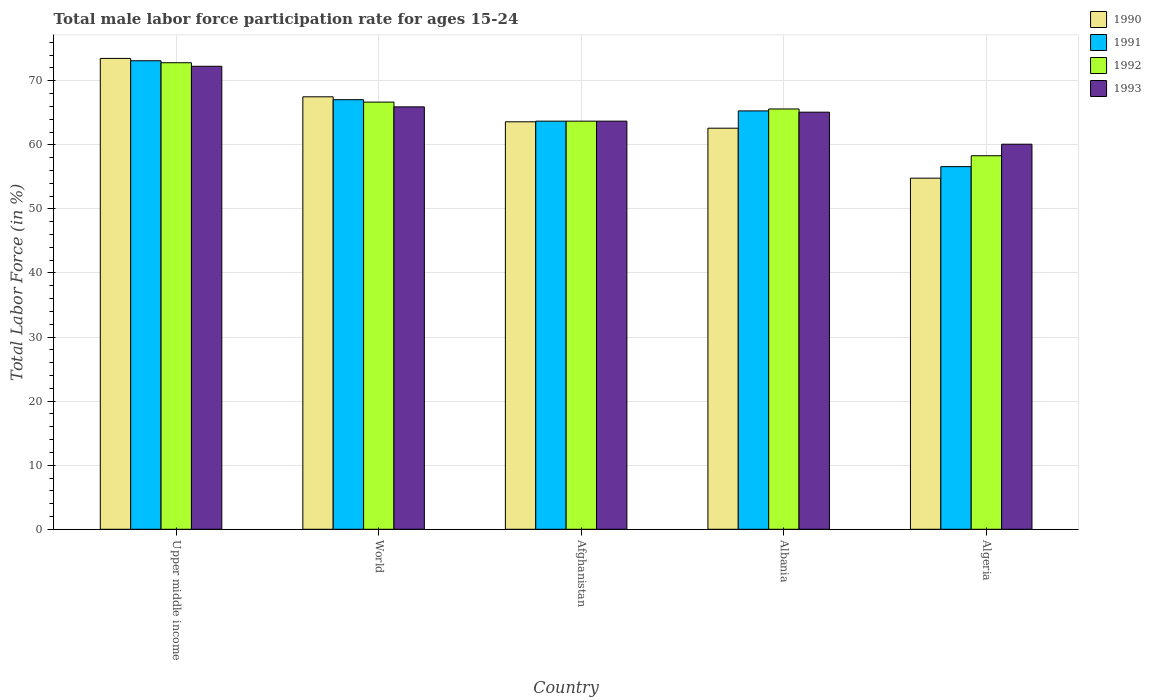How many bars are there on the 4th tick from the left?
Ensure brevity in your answer.  4. How many bars are there on the 3rd tick from the right?
Make the answer very short. 4. What is the label of the 5th group of bars from the left?
Make the answer very short. Algeria. What is the male labor force participation rate in 1991 in Afghanistan?
Your answer should be very brief. 63.7. Across all countries, what is the maximum male labor force participation rate in 1993?
Give a very brief answer. 72.26. Across all countries, what is the minimum male labor force participation rate in 1993?
Give a very brief answer. 60.1. In which country was the male labor force participation rate in 1990 maximum?
Ensure brevity in your answer.  Upper middle income. In which country was the male labor force participation rate in 1993 minimum?
Your answer should be compact. Algeria. What is the total male labor force participation rate in 1993 in the graph?
Provide a short and direct response. 327.09. What is the difference between the male labor force participation rate in 1992 in Algeria and that in World?
Provide a short and direct response. -8.37. What is the difference between the male labor force participation rate in 1992 in Upper middle income and the male labor force participation rate in 1990 in Albania?
Your answer should be very brief. 10.22. What is the average male labor force participation rate in 1991 per country?
Offer a terse response. 65.16. What is the difference between the male labor force participation rate of/in 1992 and male labor force participation rate of/in 1993 in Albania?
Your answer should be compact. 0.5. In how many countries, is the male labor force participation rate in 1992 greater than 10 %?
Your answer should be compact. 5. What is the ratio of the male labor force participation rate in 1992 in Afghanistan to that in Algeria?
Your answer should be very brief. 1.09. What is the difference between the highest and the second highest male labor force participation rate in 1990?
Make the answer very short. 5.99. What is the difference between the highest and the lowest male labor force participation rate in 1992?
Offer a terse response. 14.52. Is the sum of the male labor force participation rate in 1993 in Upper middle income and World greater than the maximum male labor force participation rate in 1991 across all countries?
Give a very brief answer. Yes. What does the 4th bar from the left in Albania represents?
Your answer should be very brief. 1993. What does the 4th bar from the right in Afghanistan represents?
Your answer should be very brief. 1990. Is it the case that in every country, the sum of the male labor force participation rate in 1991 and male labor force participation rate in 1992 is greater than the male labor force participation rate in 1990?
Your answer should be compact. Yes. Are all the bars in the graph horizontal?
Ensure brevity in your answer.  No. Are the values on the major ticks of Y-axis written in scientific E-notation?
Ensure brevity in your answer.  No. Does the graph contain any zero values?
Ensure brevity in your answer.  No. How many legend labels are there?
Provide a succinct answer. 4. How are the legend labels stacked?
Provide a short and direct response. Vertical. What is the title of the graph?
Ensure brevity in your answer.  Total male labor force participation rate for ages 15-24. What is the label or title of the X-axis?
Offer a very short reply. Country. What is the label or title of the Y-axis?
Your response must be concise. Total Labor Force (in %). What is the Total Labor Force (in %) in 1990 in Upper middle income?
Ensure brevity in your answer.  73.49. What is the Total Labor Force (in %) of 1991 in Upper middle income?
Make the answer very short. 73.13. What is the Total Labor Force (in %) in 1992 in Upper middle income?
Your answer should be compact. 72.82. What is the Total Labor Force (in %) in 1993 in Upper middle income?
Provide a short and direct response. 72.26. What is the Total Labor Force (in %) in 1990 in World?
Provide a succinct answer. 67.5. What is the Total Labor Force (in %) of 1991 in World?
Offer a terse response. 67.05. What is the Total Labor Force (in %) in 1992 in World?
Keep it short and to the point. 66.67. What is the Total Labor Force (in %) of 1993 in World?
Make the answer very short. 65.93. What is the Total Labor Force (in %) of 1990 in Afghanistan?
Give a very brief answer. 63.6. What is the Total Labor Force (in %) in 1991 in Afghanistan?
Ensure brevity in your answer.  63.7. What is the Total Labor Force (in %) in 1992 in Afghanistan?
Offer a terse response. 63.7. What is the Total Labor Force (in %) in 1993 in Afghanistan?
Offer a very short reply. 63.7. What is the Total Labor Force (in %) in 1990 in Albania?
Keep it short and to the point. 62.6. What is the Total Labor Force (in %) of 1991 in Albania?
Offer a terse response. 65.3. What is the Total Labor Force (in %) of 1992 in Albania?
Give a very brief answer. 65.6. What is the Total Labor Force (in %) in 1993 in Albania?
Give a very brief answer. 65.1. What is the Total Labor Force (in %) of 1990 in Algeria?
Provide a succinct answer. 54.8. What is the Total Labor Force (in %) in 1991 in Algeria?
Your response must be concise. 56.6. What is the Total Labor Force (in %) of 1992 in Algeria?
Offer a very short reply. 58.3. What is the Total Labor Force (in %) of 1993 in Algeria?
Provide a succinct answer. 60.1. Across all countries, what is the maximum Total Labor Force (in %) of 1990?
Keep it short and to the point. 73.49. Across all countries, what is the maximum Total Labor Force (in %) in 1991?
Offer a very short reply. 73.13. Across all countries, what is the maximum Total Labor Force (in %) in 1992?
Provide a succinct answer. 72.82. Across all countries, what is the maximum Total Labor Force (in %) in 1993?
Make the answer very short. 72.26. Across all countries, what is the minimum Total Labor Force (in %) of 1990?
Your response must be concise. 54.8. Across all countries, what is the minimum Total Labor Force (in %) of 1991?
Your answer should be compact. 56.6. Across all countries, what is the minimum Total Labor Force (in %) in 1992?
Offer a terse response. 58.3. Across all countries, what is the minimum Total Labor Force (in %) in 1993?
Provide a short and direct response. 60.1. What is the total Total Labor Force (in %) of 1990 in the graph?
Ensure brevity in your answer.  321.99. What is the total Total Labor Force (in %) in 1991 in the graph?
Provide a short and direct response. 325.78. What is the total Total Labor Force (in %) of 1992 in the graph?
Keep it short and to the point. 327.09. What is the total Total Labor Force (in %) of 1993 in the graph?
Make the answer very short. 327.09. What is the difference between the Total Labor Force (in %) in 1990 in Upper middle income and that in World?
Your answer should be very brief. 5.99. What is the difference between the Total Labor Force (in %) in 1991 in Upper middle income and that in World?
Your answer should be compact. 6.07. What is the difference between the Total Labor Force (in %) of 1992 in Upper middle income and that in World?
Ensure brevity in your answer.  6.15. What is the difference between the Total Labor Force (in %) in 1993 in Upper middle income and that in World?
Give a very brief answer. 6.33. What is the difference between the Total Labor Force (in %) in 1990 in Upper middle income and that in Afghanistan?
Your response must be concise. 9.89. What is the difference between the Total Labor Force (in %) of 1991 in Upper middle income and that in Afghanistan?
Give a very brief answer. 9.43. What is the difference between the Total Labor Force (in %) in 1992 in Upper middle income and that in Afghanistan?
Your response must be concise. 9.12. What is the difference between the Total Labor Force (in %) of 1993 in Upper middle income and that in Afghanistan?
Give a very brief answer. 8.56. What is the difference between the Total Labor Force (in %) in 1990 in Upper middle income and that in Albania?
Your answer should be very brief. 10.89. What is the difference between the Total Labor Force (in %) of 1991 in Upper middle income and that in Albania?
Your answer should be compact. 7.83. What is the difference between the Total Labor Force (in %) of 1992 in Upper middle income and that in Albania?
Keep it short and to the point. 7.22. What is the difference between the Total Labor Force (in %) in 1993 in Upper middle income and that in Albania?
Your response must be concise. 7.16. What is the difference between the Total Labor Force (in %) of 1990 in Upper middle income and that in Algeria?
Your response must be concise. 18.69. What is the difference between the Total Labor Force (in %) of 1991 in Upper middle income and that in Algeria?
Provide a succinct answer. 16.53. What is the difference between the Total Labor Force (in %) in 1992 in Upper middle income and that in Algeria?
Ensure brevity in your answer.  14.52. What is the difference between the Total Labor Force (in %) in 1993 in Upper middle income and that in Algeria?
Provide a short and direct response. 12.16. What is the difference between the Total Labor Force (in %) of 1990 in World and that in Afghanistan?
Give a very brief answer. 3.9. What is the difference between the Total Labor Force (in %) in 1991 in World and that in Afghanistan?
Your answer should be compact. 3.35. What is the difference between the Total Labor Force (in %) in 1992 in World and that in Afghanistan?
Give a very brief answer. 2.97. What is the difference between the Total Labor Force (in %) in 1993 in World and that in Afghanistan?
Your response must be concise. 2.23. What is the difference between the Total Labor Force (in %) of 1990 in World and that in Albania?
Make the answer very short. 4.9. What is the difference between the Total Labor Force (in %) in 1991 in World and that in Albania?
Provide a succinct answer. 1.75. What is the difference between the Total Labor Force (in %) in 1992 in World and that in Albania?
Provide a succinct answer. 1.07. What is the difference between the Total Labor Force (in %) in 1993 in World and that in Albania?
Ensure brevity in your answer.  0.83. What is the difference between the Total Labor Force (in %) in 1990 in World and that in Algeria?
Your answer should be very brief. 12.7. What is the difference between the Total Labor Force (in %) of 1991 in World and that in Algeria?
Provide a succinct answer. 10.45. What is the difference between the Total Labor Force (in %) of 1992 in World and that in Algeria?
Make the answer very short. 8.37. What is the difference between the Total Labor Force (in %) of 1993 in World and that in Algeria?
Ensure brevity in your answer.  5.83. What is the difference between the Total Labor Force (in %) in 1990 in Afghanistan and that in Albania?
Your answer should be compact. 1. What is the difference between the Total Labor Force (in %) of 1991 in Afghanistan and that in Albania?
Ensure brevity in your answer.  -1.6. What is the difference between the Total Labor Force (in %) in 1993 in Afghanistan and that in Albania?
Make the answer very short. -1.4. What is the difference between the Total Labor Force (in %) of 1990 in Afghanistan and that in Algeria?
Provide a short and direct response. 8.8. What is the difference between the Total Labor Force (in %) in 1992 in Afghanistan and that in Algeria?
Offer a terse response. 5.4. What is the difference between the Total Labor Force (in %) of 1993 in Afghanistan and that in Algeria?
Make the answer very short. 3.6. What is the difference between the Total Labor Force (in %) in 1991 in Albania and that in Algeria?
Give a very brief answer. 8.7. What is the difference between the Total Labor Force (in %) of 1993 in Albania and that in Algeria?
Your answer should be very brief. 5. What is the difference between the Total Labor Force (in %) of 1990 in Upper middle income and the Total Labor Force (in %) of 1991 in World?
Keep it short and to the point. 6.44. What is the difference between the Total Labor Force (in %) in 1990 in Upper middle income and the Total Labor Force (in %) in 1992 in World?
Keep it short and to the point. 6.82. What is the difference between the Total Labor Force (in %) of 1990 in Upper middle income and the Total Labor Force (in %) of 1993 in World?
Your answer should be compact. 7.56. What is the difference between the Total Labor Force (in %) in 1991 in Upper middle income and the Total Labor Force (in %) in 1992 in World?
Provide a succinct answer. 6.45. What is the difference between the Total Labor Force (in %) of 1991 in Upper middle income and the Total Labor Force (in %) of 1993 in World?
Provide a short and direct response. 7.2. What is the difference between the Total Labor Force (in %) in 1992 in Upper middle income and the Total Labor Force (in %) in 1993 in World?
Make the answer very short. 6.89. What is the difference between the Total Labor Force (in %) in 1990 in Upper middle income and the Total Labor Force (in %) in 1991 in Afghanistan?
Offer a terse response. 9.79. What is the difference between the Total Labor Force (in %) in 1990 in Upper middle income and the Total Labor Force (in %) in 1992 in Afghanistan?
Your answer should be compact. 9.79. What is the difference between the Total Labor Force (in %) in 1990 in Upper middle income and the Total Labor Force (in %) in 1993 in Afghanistan?
Ensure brevity in your answer.  9.79. What is the difference between the Total Labor Force (in %) in 1991 in Upper middle income and the Total Labor Force (in %) in 1992 in Afghanistan?
Give a very brief answer. 9.43. What is the difference between the Total Labor Force (in %) of 1991 in Upper middle income and the Total Labor Force (in %) of 1993 in Afghanistan?
Ensure brevity in your answer.  9.43. What is the difference between the Total Labor Force (in %) of 1992 in Upper middle income and the Total Labor Force (in %) of 1993 in Afghanistan?
Provide a succinct answer. 9.12. What is the difference between the Total Labor Force (in %) of 1990 in Upper middle income and the Total Labor Force (in %) of 1991 in Albania?
Provide a succinct answer. 8.19. What is the difference between the Total Labor Force (in %) in 1990 in Upper middle income and the Total Labor Force (in %) in 1992 in Albania?
Ensure brevity in your answer.  7.89. What is the difference between the Total Labor Force (in %) of 1990 in Upper middle income and the Total Labor Force (in %) of 1993 in Albania?
Provide a short and direct response. 8.39. What is the difference between the Total Labor Force (in %) in 1991 in Upper middle income and the Total Labor Force (in %) in 1992 in Albania?
Provide a succinct answer. 7.53. What is the difference between the Total Labor Force (in %) of 1991 in Upper middle income and the Total Labor Force (in %) of 1993 in Albania?
Provide a short and direct response. 8.03. What is the difference between the Total Labor Force (in %) of 1992 in Upper middle income and the Total Labor Force (in %) of 1993 in Albania?
Make the answer very short. 7.72. What is the difference between the Total Labor Force (in %) in 1990 in Upper middle income and the Total Labor Force (in %) in 1991 in Algeria?
Provide a succinct answer. 16.89. What is the difference between the Total Labor Force (in %) of 1990 in Upper middle income and the Total Labor Force (in %) of 1992 in Algeria?
Your answer should be very brief. 15.19. What is the difference between the Total Labor Force (in %) in 1990 in Upper middle income and the Total Labor Force (in %) in 1993 in Algeria?
Give a very brief answer. 13.39. What is the difference between the Total Labor Force (in %) in 1991 in Upper middle income and the Total Labor Force (in %) in 1992 in Algeria?
Your answer should be compact. 14.83. What is the difference between the Total Labor Force (in %) in 1991 in Upper middle income and the Total Labor Force (in %) in 1993 in Algeria?
Ensure brevity in your answer.  13.03. What is the difference between the Total Labor Force (in %) in 1992 in Upper middle income and the Total Labor Force (in %) in 1993 in Algeria?
Ensure brevity in your answer.  12.72. What is the difference between the Total Labor Force (in %) of 1990 in World and the Total Labor Force (in %) of 1991 in Afghanistan?
Give a very brief answer. 3.8. What is the difference between the Total Labor Force (in %) in 1990 in World and the Total Labor Force (in %) in 1992 in Afghanistan?
Keep it short and to the point. 3.8. What is the difference between the Total Labor Force (in %) in 1990 in World and the Total Labor Force (in %) in 1993 in Afghanistan?
Your answer should be very brief. 3.8. What is the difference between the Total Labor Force (in %) in 1991 in World and the Total Labor Force (in %) in 1992 in Afghanistan?
Provide a succinct answer. 3.35. What is the difference between the Total Labor Force (in %) of 1991 in World and the Total Labor Force (in %) of 1993 in Afghanistan?
Make the answer very short. 3.35. What is the difference between the Total Labor Force (in %) in 1992 in World and the Total Labor Force (in %) in 1993 in Afghanistan?
Keep it short and to the point. 2.97. What is the difference between the Total Labor Force (in %) in 1990 in World and the Total Labor Force (in %) in 1991 in Albania?
Keep it short and to the point. 2.2. What is the difference between the Total Labor Force (in %) of 1990 in World and the Total Labor Force (in %) of 1992 in Albania?
Your answer should be very brief. 1.9. What is the difference between the Total Labor Force (in %) in 1990 in World and the Total Labor Force (in %) in 1993 in Albania?
Offer a terse response. 2.4. What is the difference between the Total Labor Force (in %) in 1991 in World and the Total Labor Force (in %) in 1992 in Albania?
Make the answer very short. 1.45. What is the difference between the Total Labor Force (in %) of 1991 in World and the Total Labor Force (in %) of 1993 in Albania?
Offer a terse response. 1.95. What is the difference between the Total Labor Force (in %) in 1992 in World and the Total Labor Force (in %) in 1993 in Albania?
Keep it short and to the point. 1.57. What is the difference between the Total Labor Force (in %) of 1990 in World and the Total Labor Force (in %) of 1991 in Algeria?
Ensure brevity in your answer.  10.9. What is the difference between the Total Labor Force (in %) in 1990 in World and the Total Labor Force (in %) in 1992 in Algeria?
Offer a very short reply. 9.2. What is the difference between the Total Labor Force (in %) in 1990 in World and the Total Labor Force (in %) in 1993 in Algeria?
Keep it short and to the point. 7.4. What is the difference between the Total Labor Force (in %) of 1991 in World and the Total Labor Force (in %) of 1992 in Algeria?
Offer a terse response. 8.75. What is the difference between the Total Labor Force (in %) of 1991 in World and the Total Labor Force (in %) of 1993 in Algeria?
Provide a succinct answer. 6.95. What is the difference between the Total Labor Force (in %) in 1992 in World and the Total Labor Force (in %) in 1993 in Algeria?
Provide a short and direct response. 6.57. What is the difference between the Total Labor Force (in %) in 1990 in Afghanistan and the Total Labor Force (in %) in 1991 in Albania?
Keep it short and to the point. -1.7. What is the difference between the Total Labor Force (in %) of 1991 in Afghanistan and the Total Labor Force (in %) of 1992 in Albania?
Ensure brevity in your answer.  -1.9. What is the difference between the Total Labor Force (in %) of 1991 in Afghanistan and the Total Labor Force (in %) of 1993 in Albania?
Your answer should be very brief. -1.4. What is the difference between the Total Labor Force (in %) in 1990 in Afghanistan and the Total Labor Force (in %) in 1991 in Algeria?
Give a very brief answer. 7. What is the difference between the Total Labor Force (in %) of 1990 in Afghanistan and the Total Labor Force (in %) of 1993 in Algeria?
Give a very brief answer. 3.5. What is the difference between the Total Labor Force (in %) in 1991 in Afghanistan and the Total Labor Force (in %) in 1992 in Algeria?
Keep it short and to the point. 5.4. What is the difference between the Total Labor Force (in %) in 1991 in Afghanistan and the Total Labor Force (in %) in 1993 in Algeria?
Provide a succinct answer. 3.6. What is the difference between the Total Labor Force (in %) of 1990 in Albania and the Total Labor Force (in %) of 1991 in Algeria?
Give a very brief answer. 6. What is the difference between the Total Labor Force (in %) of 1991 in Albania and the Total Labor Force (in %) of 1992 in Algeria?
Offer a very short reply. 7. What is the difference between the Total Labor Force (in %) in 1991 in Albania and the Total Labor Force (in %) in 1993 in Algeria?
Offer a terse response. 5.2. What is the average Total Labor Force (in %) of 1990 per country?
Your answer should be compact. 64.4. What is the average Total Labor Force (in %) in 1991 per country?
Your response must be concise. 65.16. What is the average Total Labor Force (in %) of 1992 per country?
Offer a very short reply. 65.42. What is the average Total Labor Force (in %) of 1993 per country?
Your response must be concise. 65.42. What is the difference between the Total Labor Force (in %) in 1990 and Total Labor Force (in %) in 1991 in Upper middle income?
Offer a terse response. 0.37. What is the difference between the Total Labor Force (in %) in 1990 and Total Labor Force (in %) in 1992 in Upper middle income?
Keep it short and to the point. 0.67. What is the difference between the Total Labor Force (in %) in 1990 and Total Labor Force (in %) in 1993 in Upper middle income?
Offer a terse response. 1.23. What is the difference between the Total Labor Force (in %) in 1991 and Total Labor Force (in %) in 1992 in Upper middle income?
Your answer should be compact. 0.31. What is the difference between the Total Labor Force (in %) of 1991 and Total Labor Force (in %) of 1993 in Upper middle income?
Offer a terse response. 0.86. What is the difference between the Total Labor Force (in %) in 1992 and Total Labor Force (in %) in 1993 in Upper middle income?
Offer a terse response. 0.56. What is the difference between the Total Labor Force (in %) in 1990 and Total Labor Force (in %) in 1991 in World?
Keep it short and to the point. 0.45. What is the difference between the Total Labor Force (in %) in 1990 and Total Labor Force (in %) in 1992 in World?
Provide a short and direct response. 0.83. What is the difference between the Total Labor Force (in %) in 1990 and Total Labor Force (in %) in 1993 in World?
Make the answer very short. 1.57. What is the difference between the Total Labor Force (in %) in 1991 and Total Labor Force (in %) in 1992 in World?
Ensure brevity in your answer.  0.38. What is the difference between the Total Labor Force (in %) in 1991 and Total Labor Force (in %) in 1993 in World?
Your response must be concise. 1.12. What is the difference between the Total Labor Force (in %) in 1992 and Total Labor Force (in %) in 1993 in World?
Keep it short and to the point. 0.74. What is the difference between the Total Labor Force (in %) in 1990 and Total Labor Force (in %) in 1991 in Afghanistan?
Your answer should be very brief. -0.1. What is the difference between the Total Labor Force (in %) in 1990 and Total Labor Force (in %) in 1992 in Afghanistan?
Offer a terse response. -0.1. What is the difference between the Total Labor Force (in %) in 1990 and Total Labor Force (in %) in 1993 in Afghanistan?
Make the answer very short. -0.1. What is the difference between the Total Labor Force (in %) of 1991 and Total Labor Force (in %) of 1992 in Afghanistan?
Offer a very short reply. 0. What is the difference between the Total Labor Force (in %) in 1991 and Total Labor Force (in %) in 1993 in Afghanistan?
Keep it short and to the point. 0. What is the difference between the Total Labor Force (in %) in 1992 and Total Labor Force (in %) in 1993 in Afghanistan?
Provide a short and direct response. 0. What is the difference between the Total Labor Force (in %) of 1990 and Total Labor Force (in %) of 1991 in Albania?
Your response must be concise. -2.7. What is the difference between the Total Labor Force (in %) in 1990 and Total Labor Force (in %) in 1992 in Albania?
Provide a short and direct response. -3. What is the difference between the Total Labor Force (in %) in 1990 and Total Labor Force (in %) in 1993 in Albania?
Make the answer very short. -2.5. What is the difference between the Total Labor Force (in %) in 1991 and Total Labor Force (in %) in 1992 in Albania?
Your answer should be compact. -0.3. What is the difference between the Total Labor Force (in %) in 1991 and Total Labor Force (in %) in 1993 in Albania?
Provide a short and direct response. 0.2. What is the difference between the Total Labor Force (in %) of 1992 and Total Labor Force (in %) of 1993 in Albania?
Your response must be concise. 0.5. What is the difference between the Total Labor Force (in %) in 1990 and Total Labor Force (in %) in 1993 in Algeria?
Keep it short and to the point. -5.3. What is the ratio of the Total Labor Force (in %) in 1990 in Upper middle income to that in World?
Provide a short and direct response. 1.09. What is the ratio of the Total Labor Force (in %) in 1991 in Upper middle income to that in World?
Your response must be concise. 1.09. What is the ratio of the Total Labor Force (in %) of 1992 in Upper middle income to that in World?
Offer a terse response. 1.09. What is the ratio of the Total Labor Force (in %) of 1993 in Upper middle income to that in World?
Keep it short and to the point. 1.1. What is the ratio of the Total Labor Force (in %) in 1990 in Upper middle income to that in Afghanistan?
Your answer should be very brief. 1.16. What is the ratio of the Total Labor Force (in %) in 1991 in Upper middle income to that in Afghanistan?
Provide a succinct answer. 1.15. What is the ratio of the Total Labor Force (in %) in 1992 in Upper middle income to that in Afghanistan?
Make the answer very short. 1.14. What is the ratio of the Total Labor Force (in %) of 1993 in Upper middle income to that in Afghanistan?
Offer a very short reply. 1.13. What is the ratio of the Total Labor Force (in %) in 1990 in Upper middle income to that in Albania?
Your answer should be compact. 1.17. What is the ratio of the Total Labor Force (in %) of 1991 in Upper middle income to that in Albania?
Offer a very short reply. 1.12. What is the ratio of the Total Labor Force (in %) in 1992 in Upper middle income to that in Albania?
Offer a very short reply. 1.11. What is the ratio of the Total Labor Force (in %) of 1993 in Upper middle income to that in Albania?
Provide a short and direct response. 1.11. What is the ratio of the Total Labor Force (in %) of 1990 in Upper middle income to that in Algeria?
Your answer should be compact. 1.34. What is the ratio of the Total Labor Force (in %) of 1991 in Upper middle income to that in Algeria?
Make the answer very short. 1.29. What is the ratio of the Total Labor Force (in %) of 1992 in Upper middle income to that in Algeria?
Your answer should be very brief. 1.25. What is the ratio of the Total Labor Force (in %) of 1993 in Upper middle income to that in Algeria?
Make the answer very short. 1.2. What is the ratio of the Total Labor Force (in %) in 1990 in World to that in Afghanistan?
Keep it short and to the point. 1.06. What is the ratio of the Total Labor Force (in %) of 1991 in World to that in Afghanistan?
Ensure brevity in your answer.  1.05. What is the ratio of the Total Labor Force (in %) of 1992 in World to that in Afghanistan?
Your response must be concise. 1.05. What is the ratio of the Total Labor Force (in %) in 1993 in World to that in Afghanistan?
Make the answer very short. 1.03. What is the ratio of the Total Labor Force (in %) in 1990 in World to that in Albania?
Your response must be concise. 1.08. What is the ratio of the Total Labor Force (in %) in 1991 in World to that in Albania?
Your response must be concise. 1.03. What is the ratio of the Total Labor Force (in %) in 1992 in World to that in Albania?
Provide a short and direct response. 1.02. What is the ratio of the Total Labor Force (in %) of 1993 in World to that in Albania?
Your response must be concise. 1.01. What is the ratio of the Total Labor Force (in %) of 1990 in World to that in Algeria?
Keep it short and to the point. 1.23. What is the ratio of the Total Labor Force (in %) in 1991 in World to that in Algeria?
Offer a terse response. 1.18. What is the ratio of the Total Labor Force (in %) of 1992 in World to that in Algeria?
Your response must be concise. 1.14. What is the ratio of the Total Labor Force (in %) in 1993 in World to that in Algeria?
Make the answer very short. 1.1. What is the ratio of the Total Labor Force (in %) of 1991 in Afghanistan to that in Albania?
Give a very brief answer. 0.98. What is the ratio of the Total Labor Force (in %) of 1992 in Afghanistan to that in Albania?
Provide a short and direct response. 0.97. What is the ratio of the Total Labor Force (in %) in 1993 in Afghanistan to that in Albania?
Your answer should be very brief. 0.98. What is the ratio of the Total Labor Force (in %) of 1990 in Afghanistan to that in Algeria?
Give a very brief answer. 1.16. What is the ratio of the Total Labor Force (in %) in 1991 in Afghanistan to that in Algeria?
Your answer should be compact. 1.13. What is the ratio of the Total Labor Force (in %) in 1992 in Afghanistan to that in Algeria?
Provide a short and direct response. 1.09. What is the ratio of the Total Labor Force (in %) of 1993 in Afghanistan to that in Algeria?
Provide a succinct answer. 1.06. What is the ratio of the Total Labor Force (in %) in 1990 in Albania to that in Algeria?
Offer a very short reply. 1.14. What is the ratio of the Total Labor Force (in %) in 1991 in Albania to that in Algeria?
Make the answer very short. 1.15. What is the ratio of the Total Labor Force (in %) in 1992 in Albania to that in Algeria?
Keep it short and to the point. 1.13. What is the ratio of the Total Labor Force (in %) in 1993 in Albania to that in Algeria?
Provide a short and direct response. 1.08. What is the difference between the highest and the second highest Total Labor Force (in %) of 1990?
Your response must be concise. 5.99. What is the difference between the highest and the second highest Total Labor Force (in %) of 1991?
Provide a short and direct response. 6.07. What is the difference between the highest and the second highest Total Labor Force (in %) in 1992?
Your response must be concise. 6.15. What is the difference between the highest and the second highest Total Labor Force (in %) of 1993?
Keep it short and to the point. 6.33. What is the difference between the highest and the lowest Total Labor Force (in %) in 1990?
Make the answer very short. 18.69. What is the difference between the highest and the lowest Total Labor Force (in %) of 1991?
Provide a short and direct response. 16.53. What is the difference between the highest and the lowest Total Labor Force (in %) in 1992?
Offer a very short reply. 14.52. What is the difference between the highest and the lowest Total Labor Force (in %) in 1993?
Offer a very short reply. 12.16. 